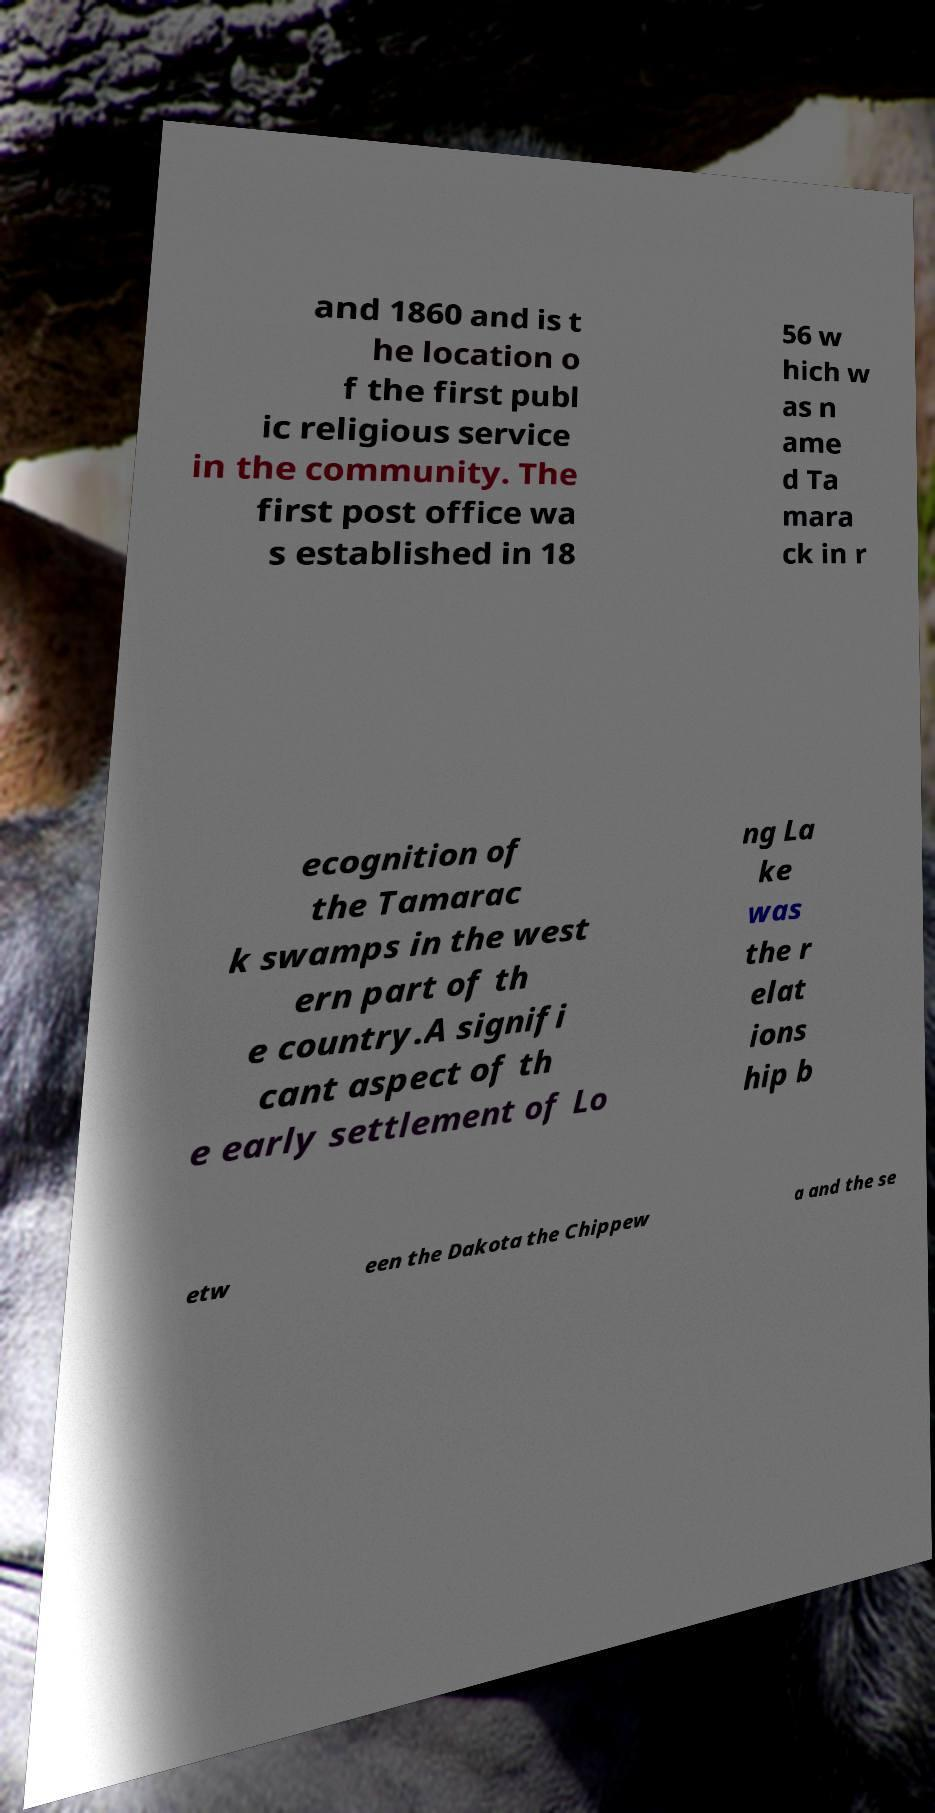Could you extract and type out the text from this image? and 1860 and is t he location o f the first publ ic religious service in the community. The first post office wa s established in 18 56 w hich w as n ame d Ta mara ck in r ecognition of the Tamarac k swamps in the west ern part of th e country.A signifi cant aspect of th e early settlement of Lo ng La ke was the r elat ions hip b etw een the Dakota the Chippew a and the se 